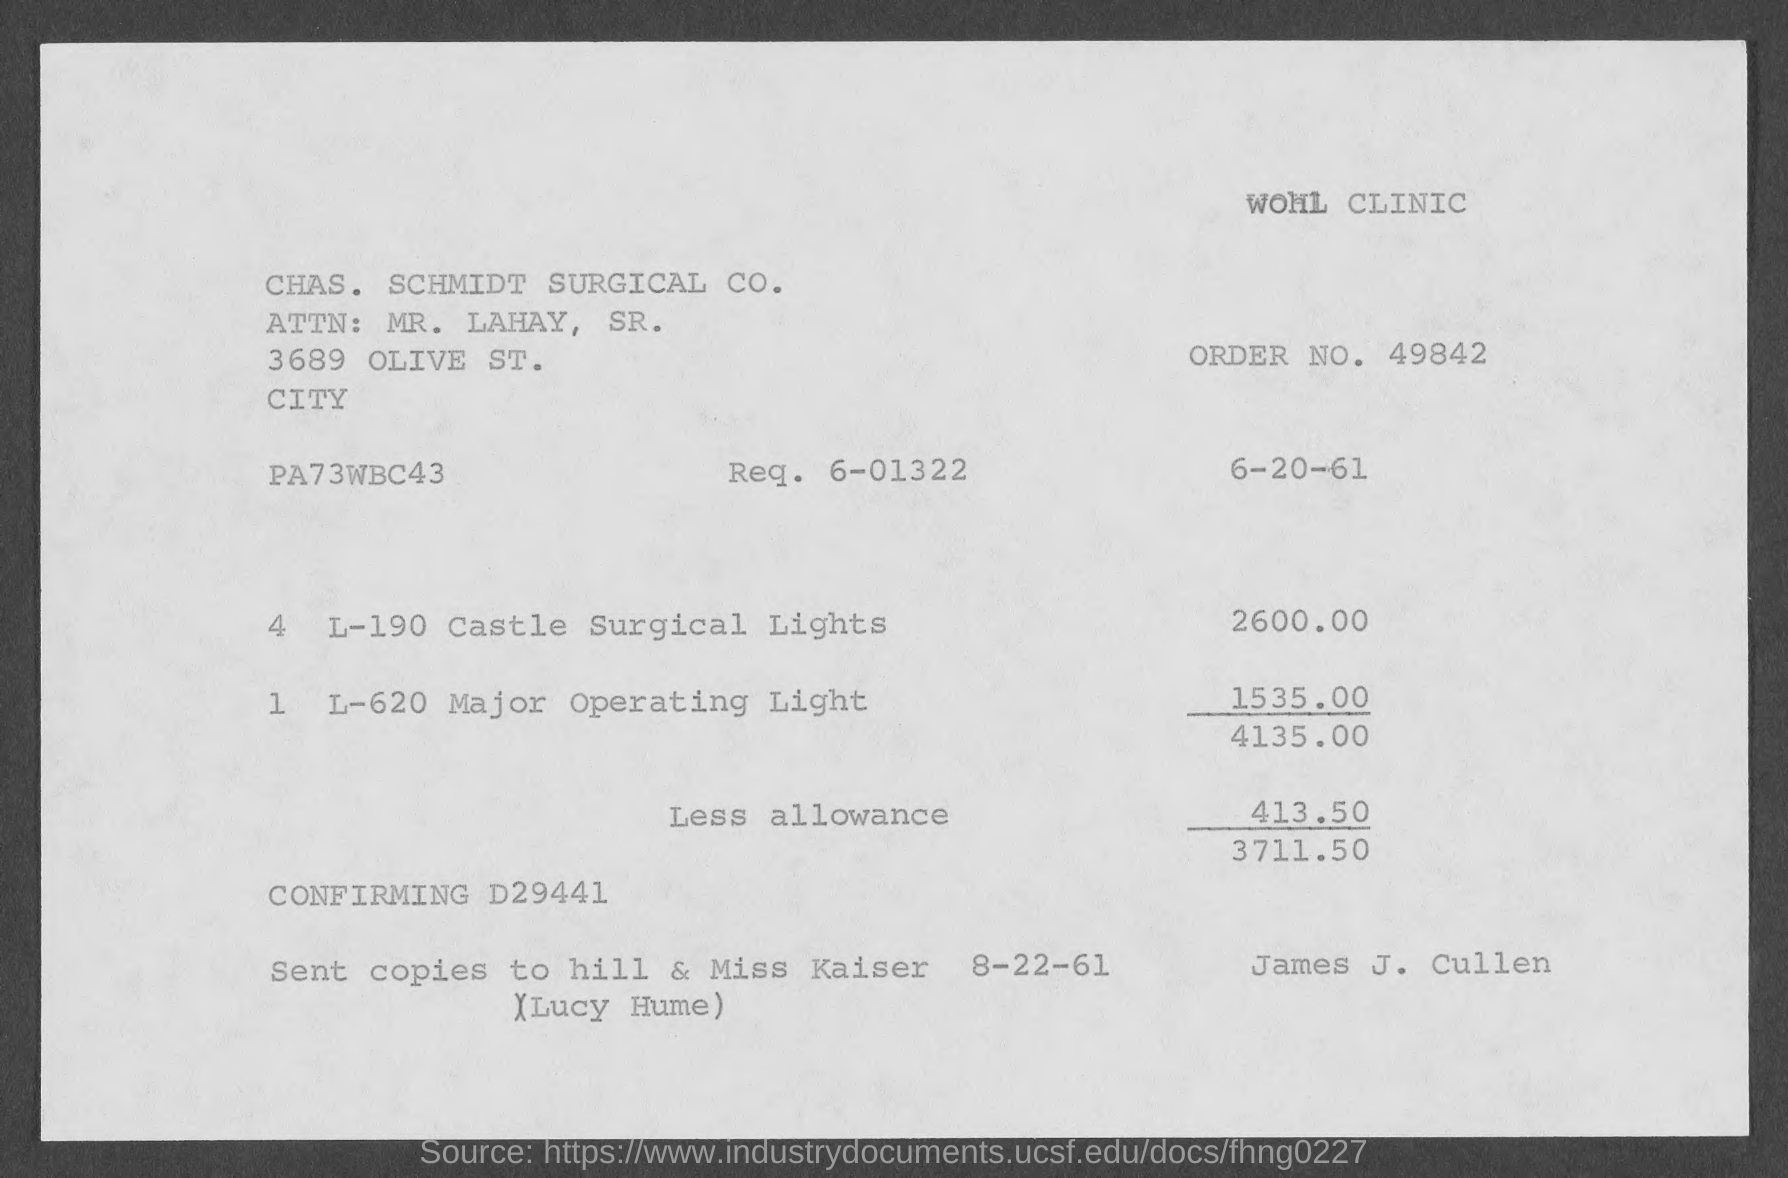what is the amount of less allowance mentioned in the given page ? The document specifies a 'Less allowance' of $413.50, which appears to be a deduction from the total amount due for the items listed, resulting in a net total of $3711.50. 